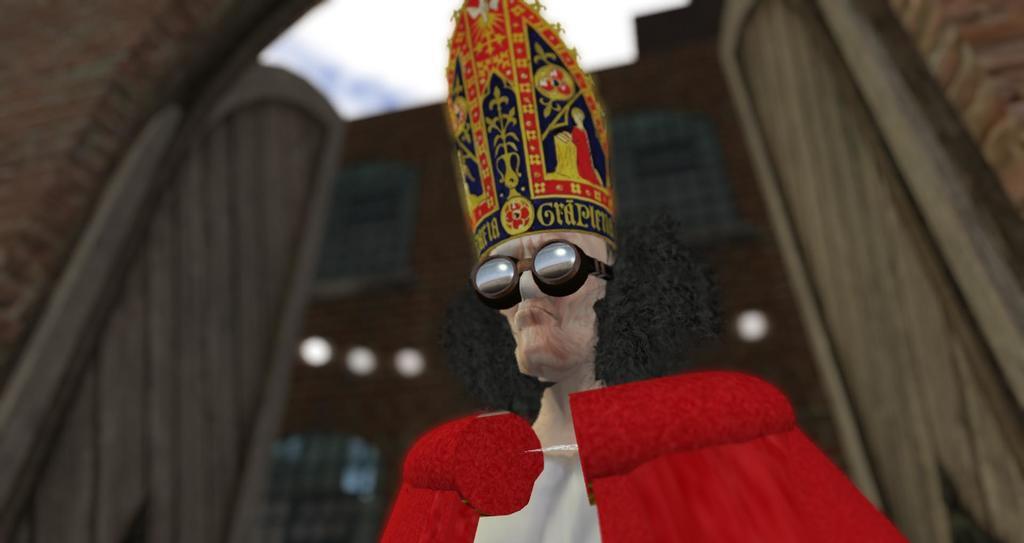In one or two sentences, can you explain what this image depicts? This is an animation and here we can see a person wearing a cap and glasses and in the background, there are buildings. 